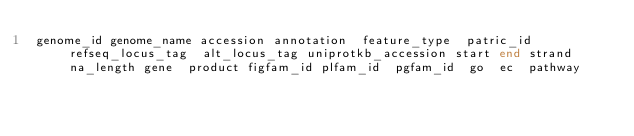Convert code to text. <code><loc_0><loc_0><loc_500><loc_500><_SQL_>genome_id	genome_name	accession	annotation	feature_type	patric_id	refseq_locus_tag	alt_locus_tag	uniprotkb_accession	start	end	strand	na_length	gene	product	figfam_id	plfam_id	pgfam_id	go	ec	pathway</code> 